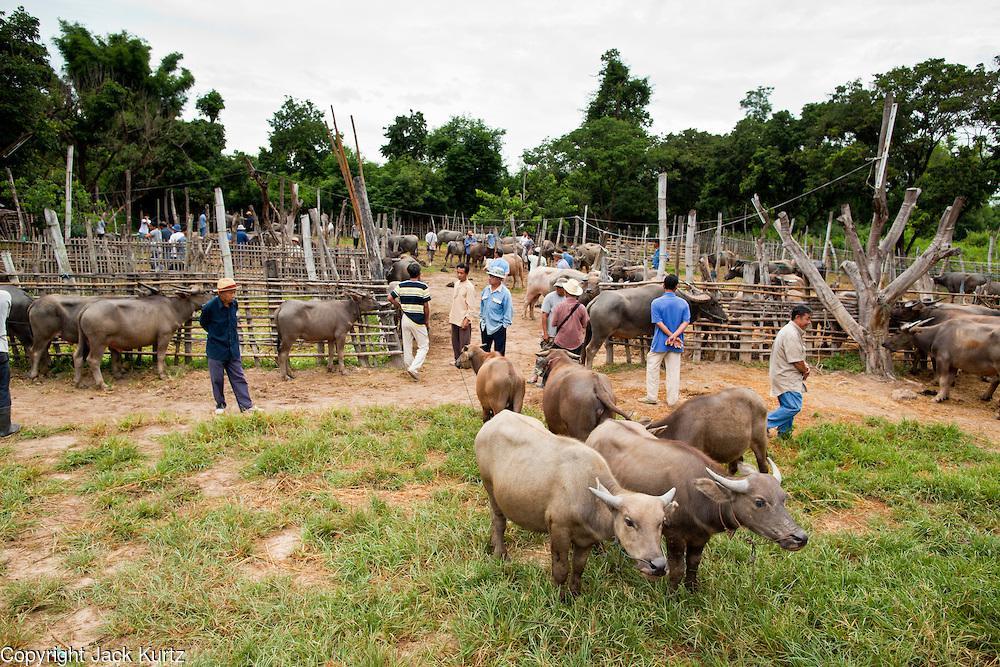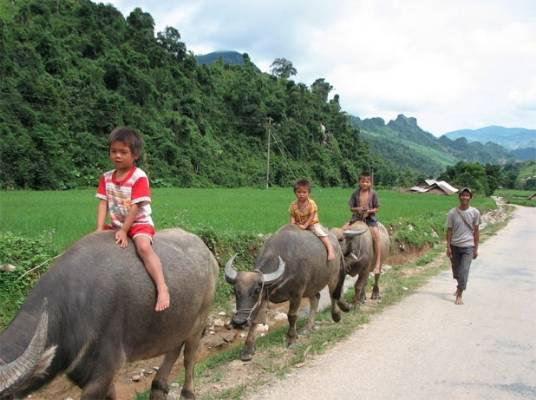The first image is the image on the left, the second image is the image on the right. Examine the images to the left and right. Is the description "The left image contains one hunter near one dead water buffalo." accurate? Answer yes or no. No. The first image is the image on the left, the second image is the image on the right. Evaluate the accuracy of this statement regarding the images: "One image shows a man holding a gun posed next to a dead water buffalo, and the other image shows at least one person riding on the back of a water buffalo.". Is it true? Answer yes or no. No. 